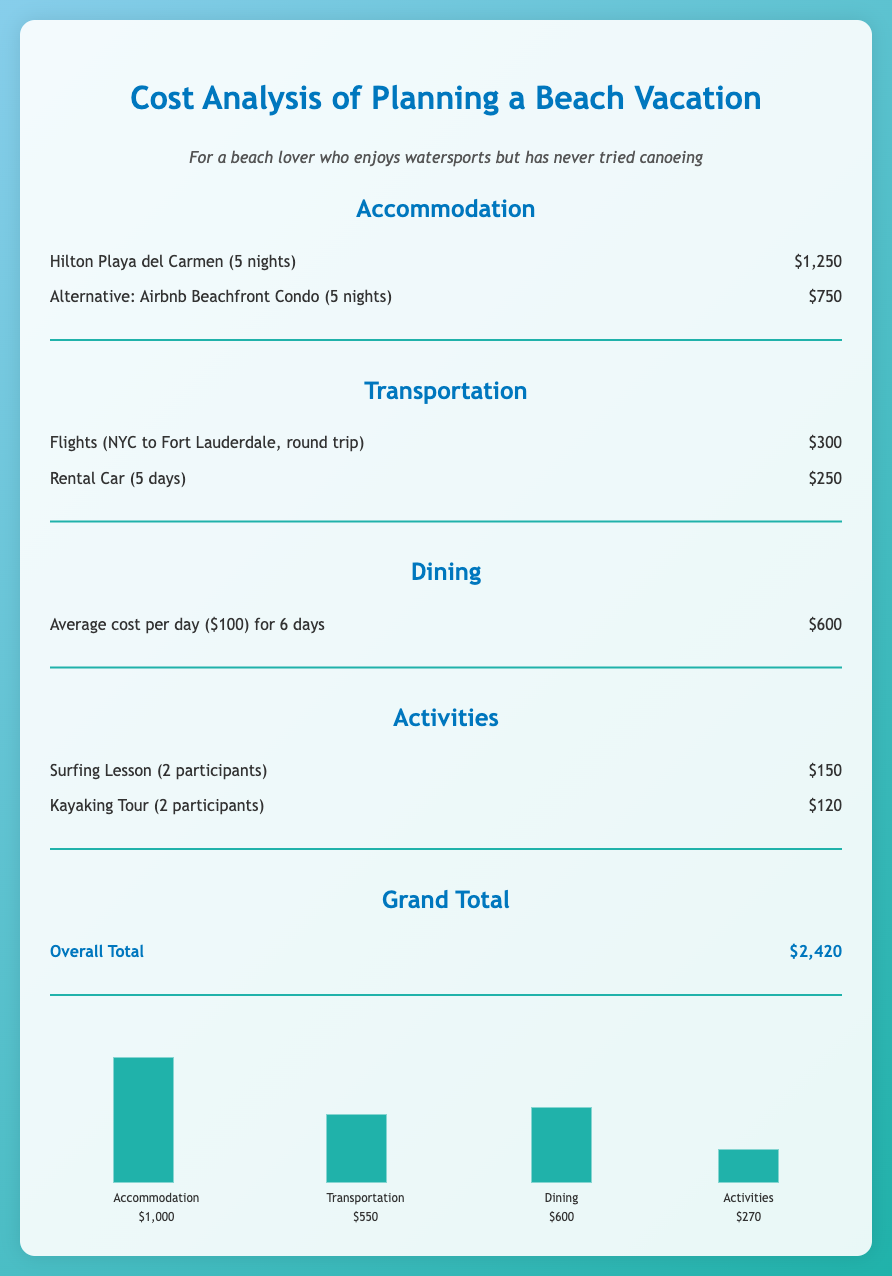What is the cost of accommodation for Hilton Playa del Carmen? The cost for Hilton Playa del Carmen for 5 nights is provided in the document, which is $1,250.
Answer: $1,250 What is the total transportation cost? The transportation costs include flights and a rental car, totaling $300 + $250 as stated in the document.
Answer: $550 How much is the average dining cost for 6 days? The document specifies the average dining cost per day is $100 for 6 days, which totals $600.
Answer: $600 What activity costs are included for two participants in the activities section? The costs for activities include a surfing lesson for $150 and a kayaking tour for $120, as seen in the document.
Answer: $270 What is the grand total for the vacation costs? The overall total for the vacation is calculated in the document and is explicitly stated as $2,420.
Answer: $2,420 How many nights is the Airbnb rental? The alternative accommodation option listed is for 5 nights.
Answer: 5 nights Which activity has the lowest cost? The kayaking tour has a cost of $120, which is less than the surfing lesson's cost of $150.
Answer: $120 What is the cost of renting a car for 5 days? The rental car cost for 5 days as outlined in the document is $250.
Answer: $250 What is the label color used for headings in the document? The headings in the document are colored in blue with the hex code mentioned as #0077be.
Answer: Blue 